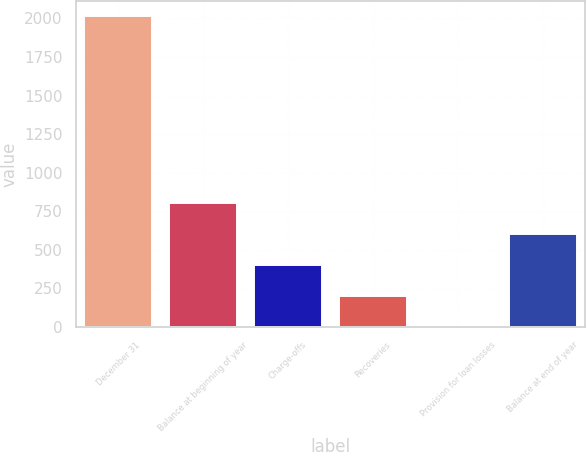Convert chart to OTSL. <chart><loc_0><loc_0><loc_500><loc_500><bar_chart><fcel>December 31<fcel>Balance at beginning of year<fcel>Charge-offs<fcel>Recoveries<fcel>Provision for loan losses<fcel>Balance at end of year<nl><fcel>2013<fcel>805.8<fcel>403.4<fcel>202.2<fcel>1<fcel>604.6<nl></chart> 